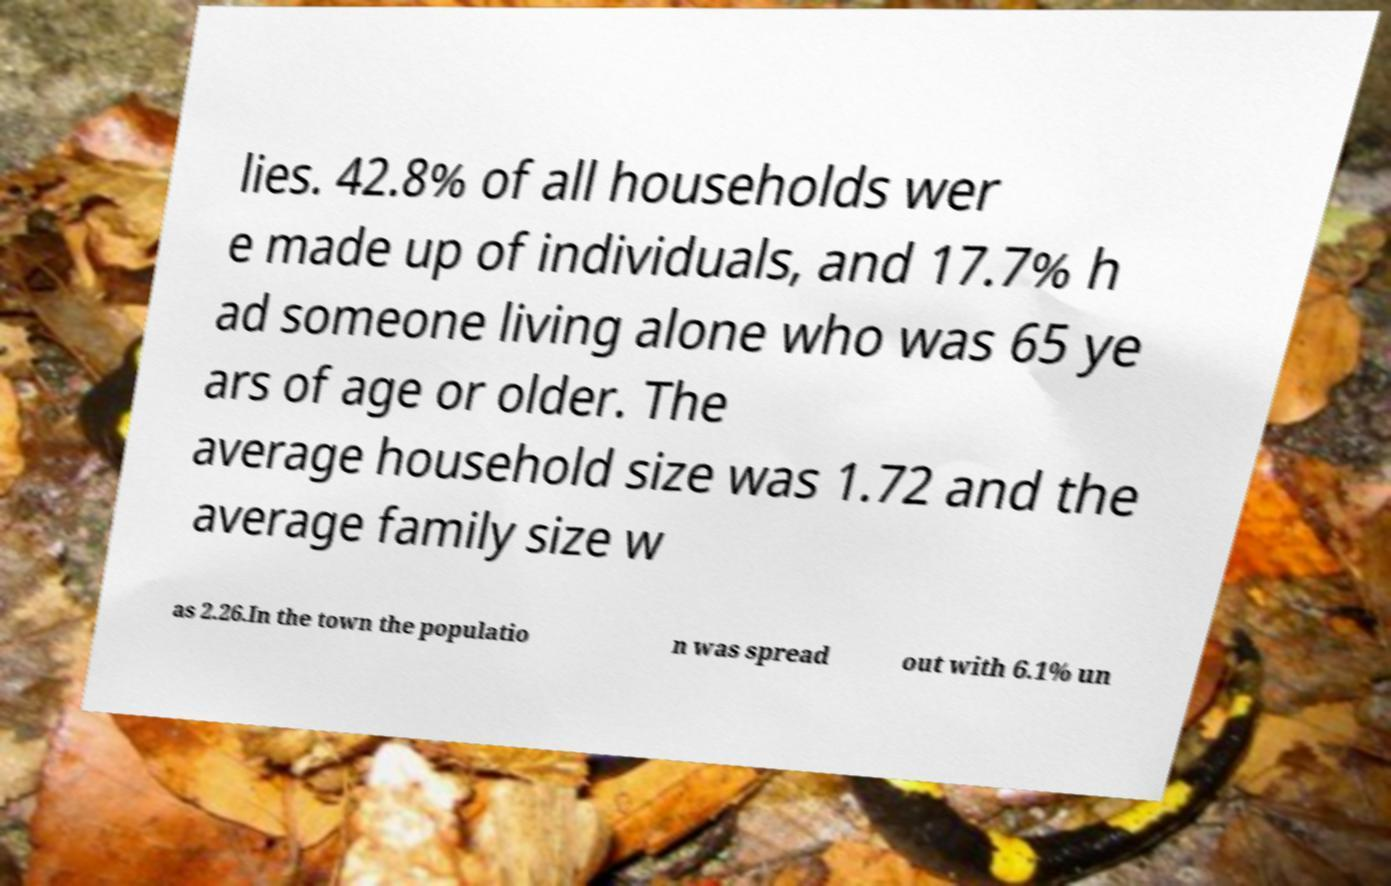For documentation purposes, I need the text within this image transcribed. Could you provide that? lies. 42.8% of all households wer e made up of individuals, and 17.7% h ad someone living alone who was 65 ye ars of age or older. The average household size was 1.72 and the average family size w as 2.26.In the town the populatio n was spread out with 6.1% un 